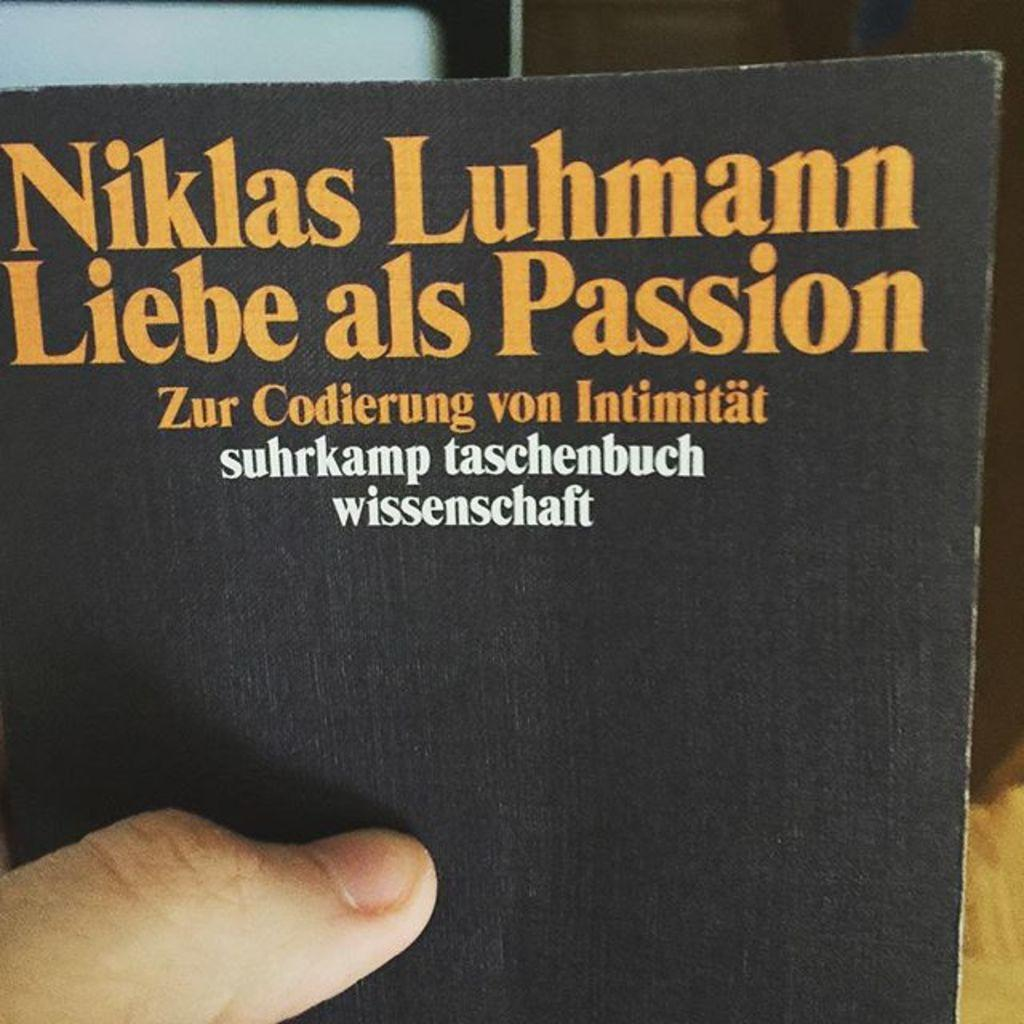<image>
Provide a brief description of the given image. One thumb on the cover of this Niklas Luhmann book shows that a person is holding it up infront of the camera. 